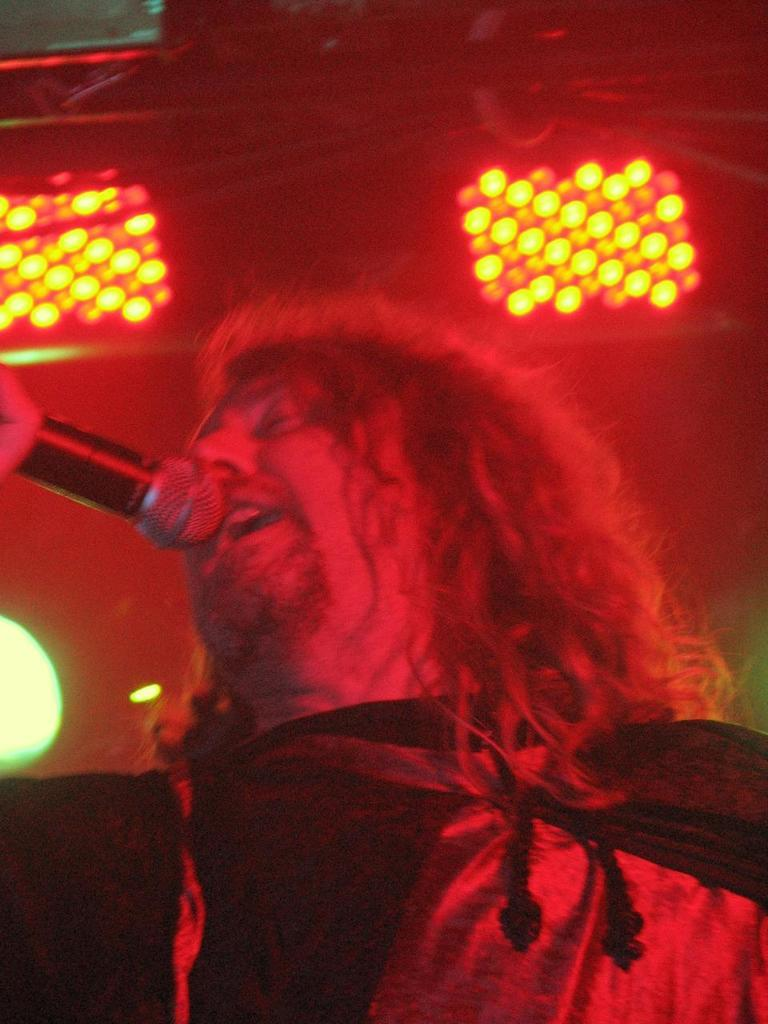Who is the main subject in the image? There is a man in the center of the image. What is the man doing in the image? The man is standing and holding a mic. What can be seen in the background of the image? There are lights in the background of the image. Are there any tents or boats visible in the image? No, there are no tents or boats present in the image. What type of soap is the man using to clean the mic in the image? There is no soap or cleaning activity depicted in the image; the man is simply holding a mic. 